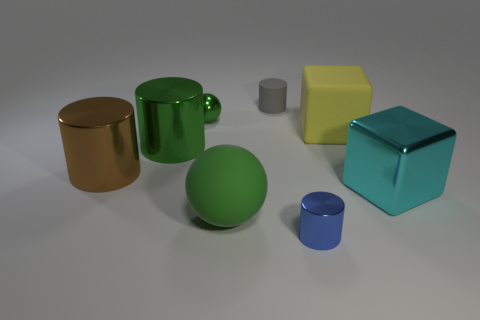Subtract 1 cylinders. How many cylinders are left? 3 Add 1 big shiny cylinders. How many objects exist? 9 Subtract all cubes. How many objects are left? 6 Add 2 big metal things. How many big metal things exist? 5 Subtract 0 gray spheres. How many objects are left? 8 Subtract all small gray cylinders. Subtract all blue shiny cylinders. How many objects are left? 6 Add 1 large brown objects. How many large brown objects are left? 2 